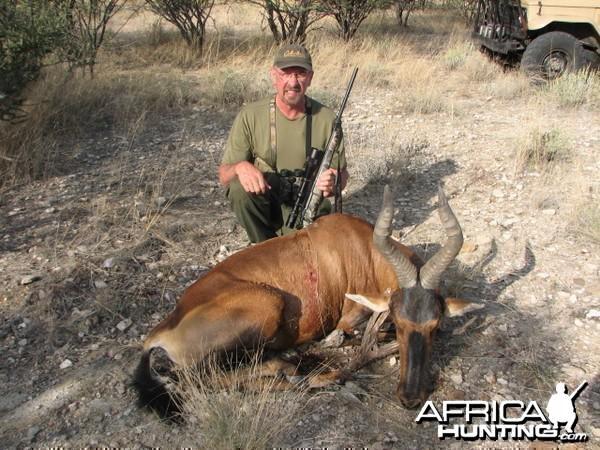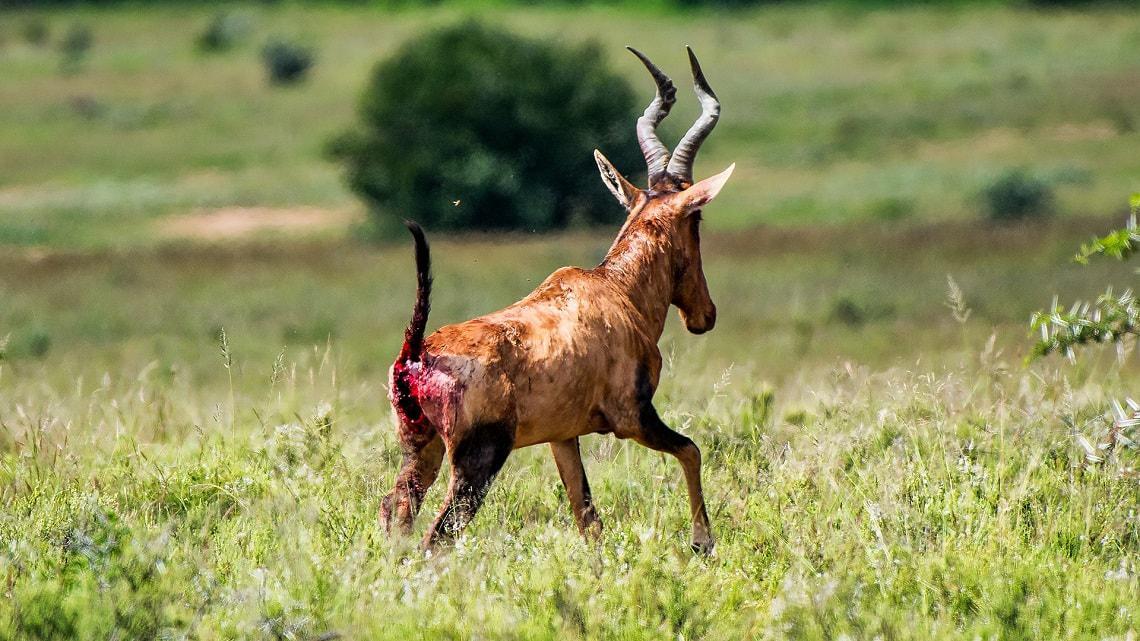The first image is the image on the left, the second image is the image on the right. For the images displayed, is the sentence "Each image contains one horned animal, and the animals on the left and right have their heads turned in the same direction." factually correct? Answer yes or no. No. The first image is the image on the left, the second image is the image on the right. For the images displayed, is the sentence "The left and right image contains the same number of standing elk." factually correct? Answer yes or no. No. 